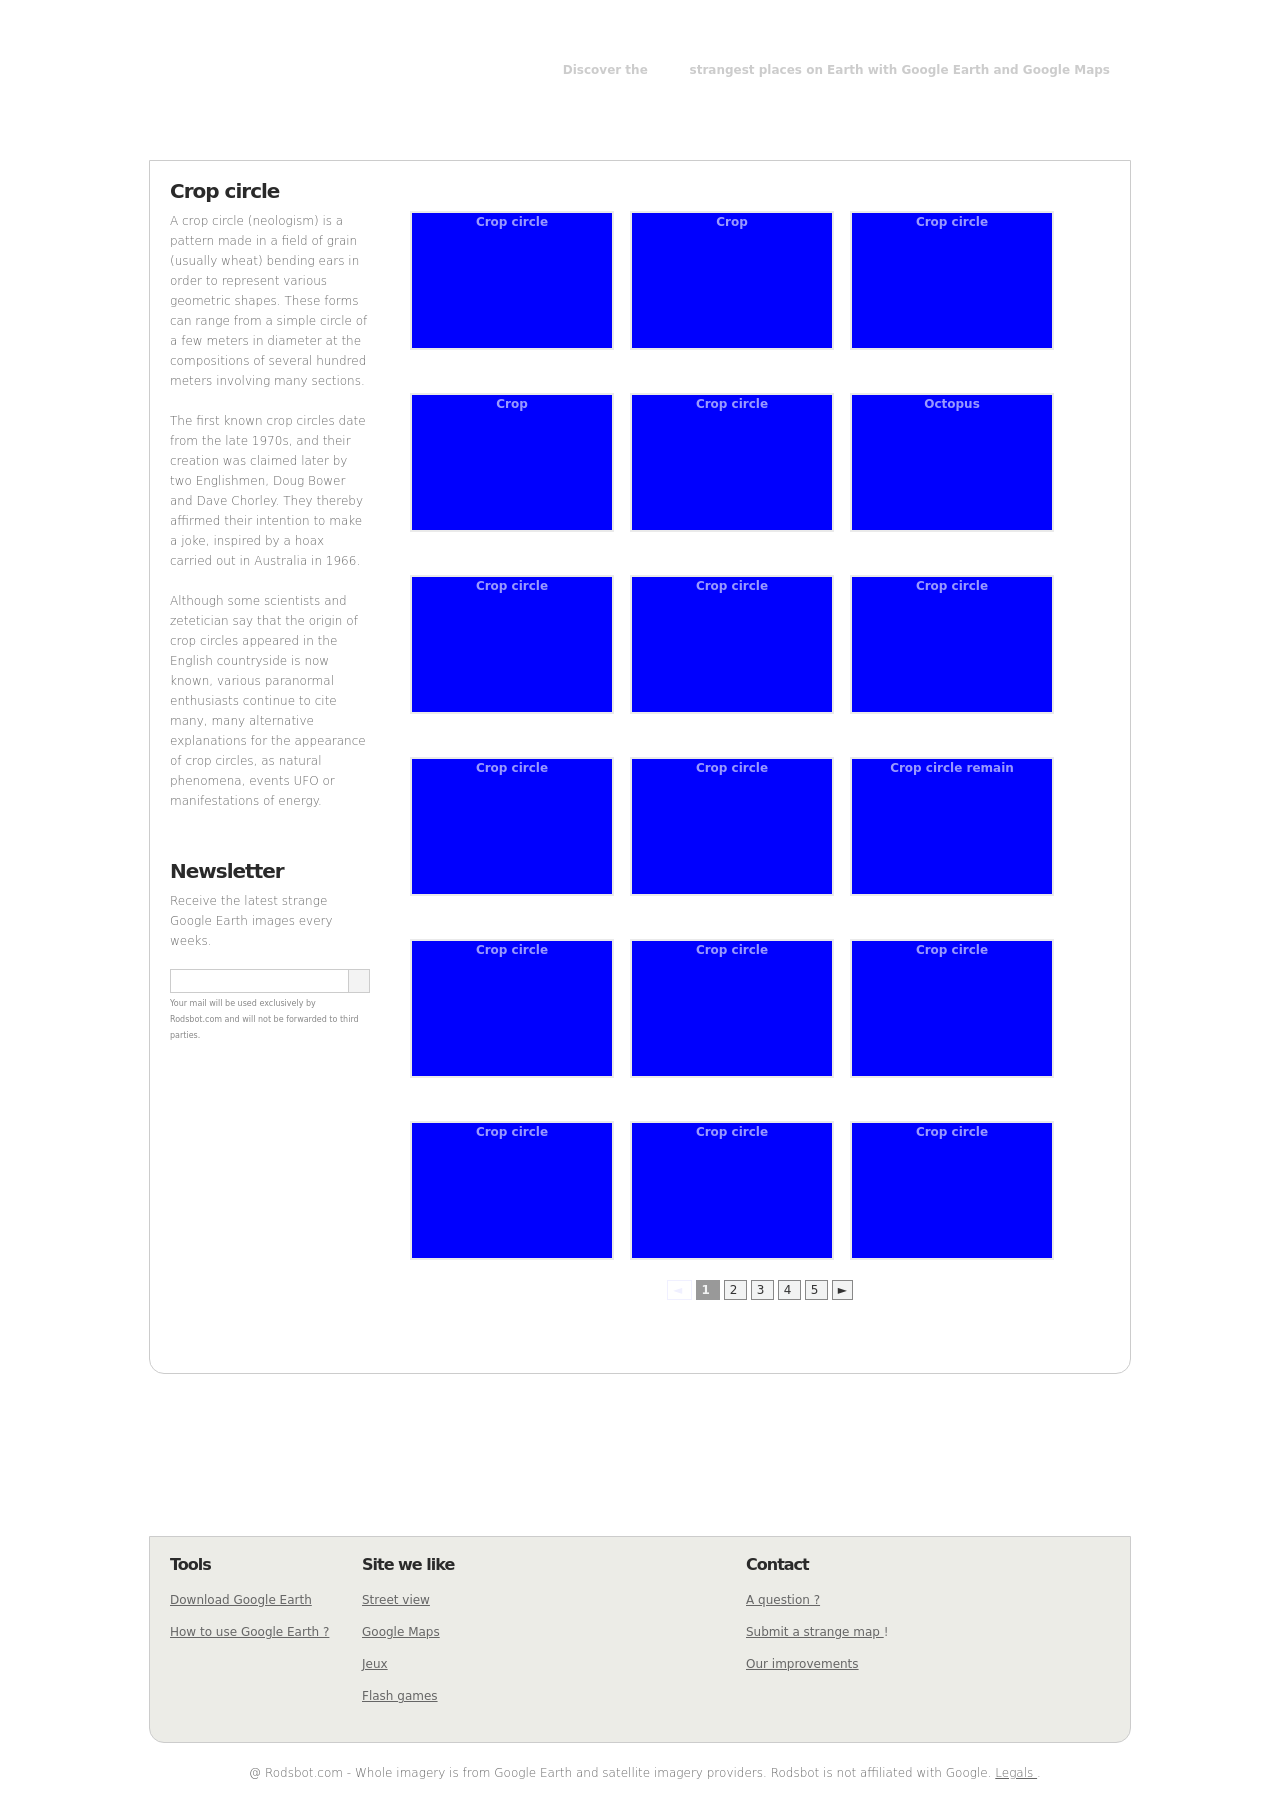What is the importance of crop circles, and why are they featured in this image collection? Crop circles are featured in this image collection due to their intriguing nature and the mystery often surrounding their origins. Historically, crop circles have fascinated both researchers and conspiracy theorists with their precise geometric patterns and unexplained appearances, usually in agricultural fields. They are featured here to highlight unusual or strange geographic patterns visible from aerial views like those provided by Google Earth, appealing to viewers' curiosities about such phenomena. 